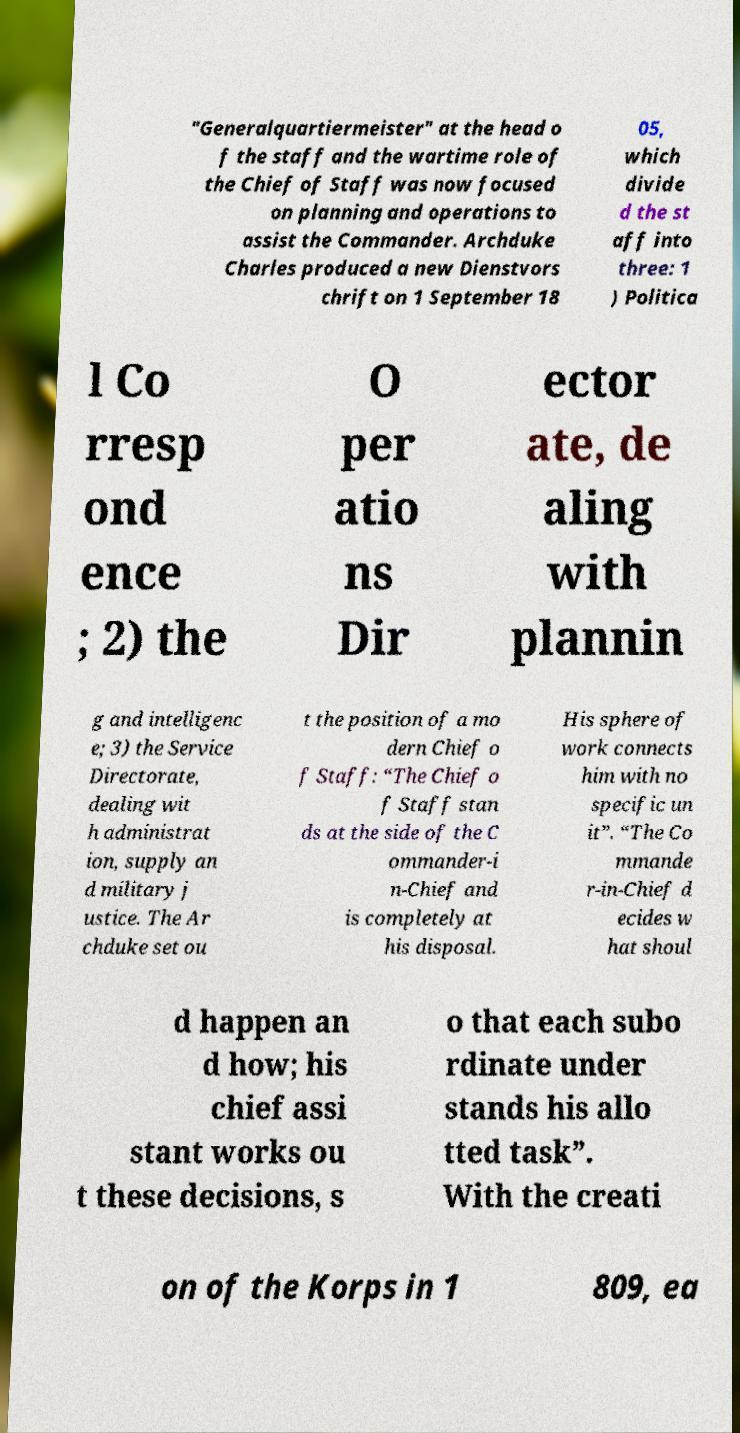For documentation purposes, I need the text within this image transcribed. Could you provide that? "Generalquartiermeister" at the head o f the staff and the wartime role of the Chief of Staff was now focused on planning and operations to assist the Commander. Archduke Charles produced a new Dienstvors chrift on 1 September 18 05, which divide d the st aff into three: 1 ) Politica l Co rresp ond ence ; 2) the O per atio ns Dir ector ate, de aling with plannin g and intelligenc e; 3) the Service Directorate, dealing wit h administrat ion, supply an d military j ustice. The Ar chduke set ou t the position of a mo dern Chief o f Staff: “The Chief o f Staff stan ds at the side of the C ommander-i n-Chief and is completely at his disposal. His sphere of work connects him with no specific un it”. “The Co mmande r-in-Chief d ecides w hat shoul d happen an d how; his chief assi stant works ou t these decisions, s o that each subo rdinate under stands his allo tted task”. With the creati on of the Korps in 1 809, ea 